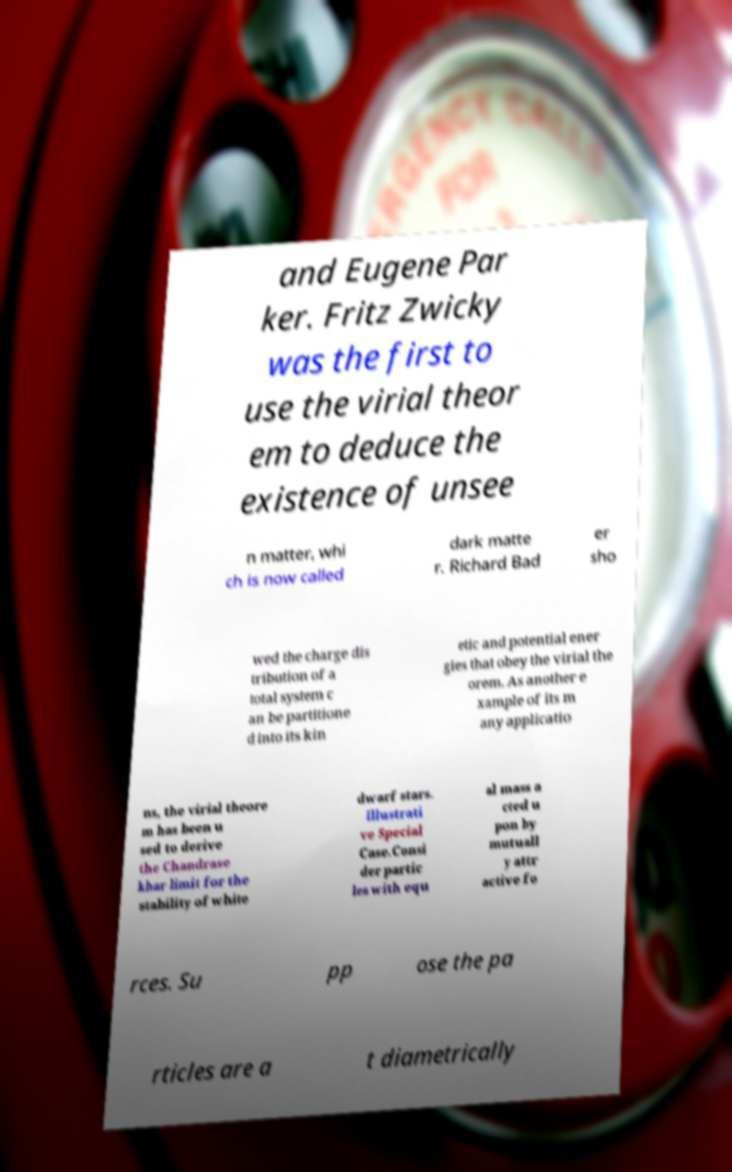Can you accurately transcribe the text from the provided image for me? and Eugene Par ker. Fritz Zwicky was the first to use the virial theor em to deduce the existence of unsee n matter, whi ch is now called dark matte r. Richard Bad er sho wed the charge dis tribution of a total system c an be partitione d into its kin etic and potential ener gies that obey the virial the orem. As another e xample of its m any applicatio ns, the virial theore m has been u sed to derive the Chandrase khar limit for the stability of white dwarf stars. Illustrati ve Special Case.Consi der partic les with equ al mass a cted u pon by mutuall y attr active fo rces. Su pp ose the pa rticles are a t diametrically 